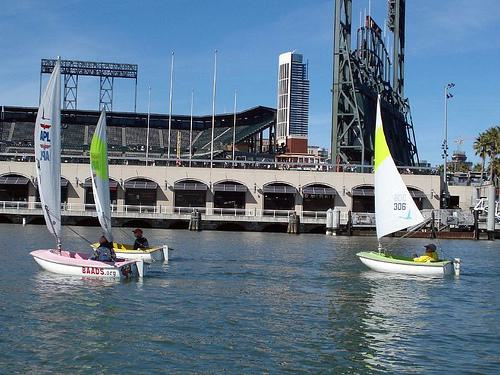How would you describe the activity taking place in the scene? This scene showcases a leisurely sailing activity, with two boats navigating the waters in close proximity to each other. This suggests a recreational or training context, rather than a competitive race, given the relaxed posture of the crews and the absence of a fleet of boats that would indicate a regatta.  Are there any safety measures apparent in the image? Yes, the crews are wearing life jackets, which is a fundamental safety measure in any sailing activity. The presence of a calm water area and the proximity to the shore also contribute to safety. Moreover, there seems to be a support boat in the background, partially visible, which is typically used to ensure the safety of the participants. 